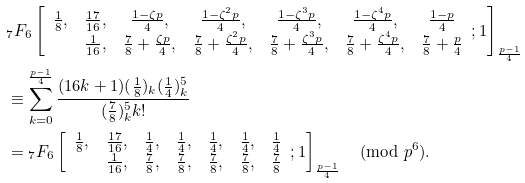<formula> <loc_0><loc_0><loc_500><loc_500>& { _ { 7 } } F _ { 6 } \left [ \begin{array} { c c c c c c c } \frac { 1 } { 8 } , & \frac { 1 7 } { 1 6 } , & \frac { 1 - \zeta p } { 4 } , & \frac { 1 - \zeta ^ { 2 } p } { 4 } , & \frac { 1 - \zeta ^ { 3 } p } { 4 } , & \frac { 1 - \zeta ^ { 4 } p } { 4 } , & \frac { 1 - p } { 4 } \\ & \frac { 1 } { 1 6 } , & \frac { 7 } { 8 } + \frac { \zeta p } { 4 } , & \frac { 7 } { 8 } + \frac { \zeta ^ { 2 } p } { 4 } , & \frac { 7 } { 8 } + \frac { \zeta ^ { 3 } p } { 4 } , & \frac { 7 } { 8 } + \frac { \zeta ^ { 4 } p } { 4 } , & \frac { 7 } { 8 } + \frac { p } { 4 } \end{array} ; 1 \right ] _ { \frac { p - 1 } { 4 } } \\ & \equiv \sum _ { k = 0 } ^ { \frac { p - 1 } { 4 } } \frac { ( 1 6 k + 1 ) ( \frac { 1 } { 8 } ) _ { k } ( \frac { 1 } { 4 } ) _ { k } ^ { 5 } } { ( \frac { 7 } { 8 } ) _ { k } ^ { 5 } k ! } \\ & = { _ { 7 } } F _ { 6 } \left [ \begin{array} { c c c c c c c } \frac { 1 } { 8 } , & \frac { 1 7 } { 1 6 } , & \frac { 1 } { 4 } , & \frac { 1 } { 4 } , & \frac { 1 } { 4 } , & \frac { 1 } { 4 } , & \frac { 1 } { 4 } \\ & \frac { 1 } { 1 6 } , & \frac { 7 } { 8 } , & \frac { 7 } { 8 } , & \frac { 7 } { 8 } , & \frac { 7 } { 8 } , & \frac { 7 } { 8 } \end{array} ; 1 \right ] _ { \frac { p - 1 } { 4 } } \pmod { p ^ { 6 } } .</formula> 